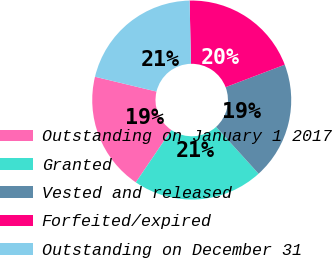Convert chart. <chart><loc_0><loc_0><loc_500><loc_500><pie_chart><fcel>Outstanding on January 1 2017<fcel>Granted<fcel>Vested and released<fcel>Forfeited/expired<fcel>Outstanding on December 31<nl><fcel>19.27%<fcel>21.22%<fcel>19.05%<fcel>19.56%<fcel>20.9%<nl></chart> 